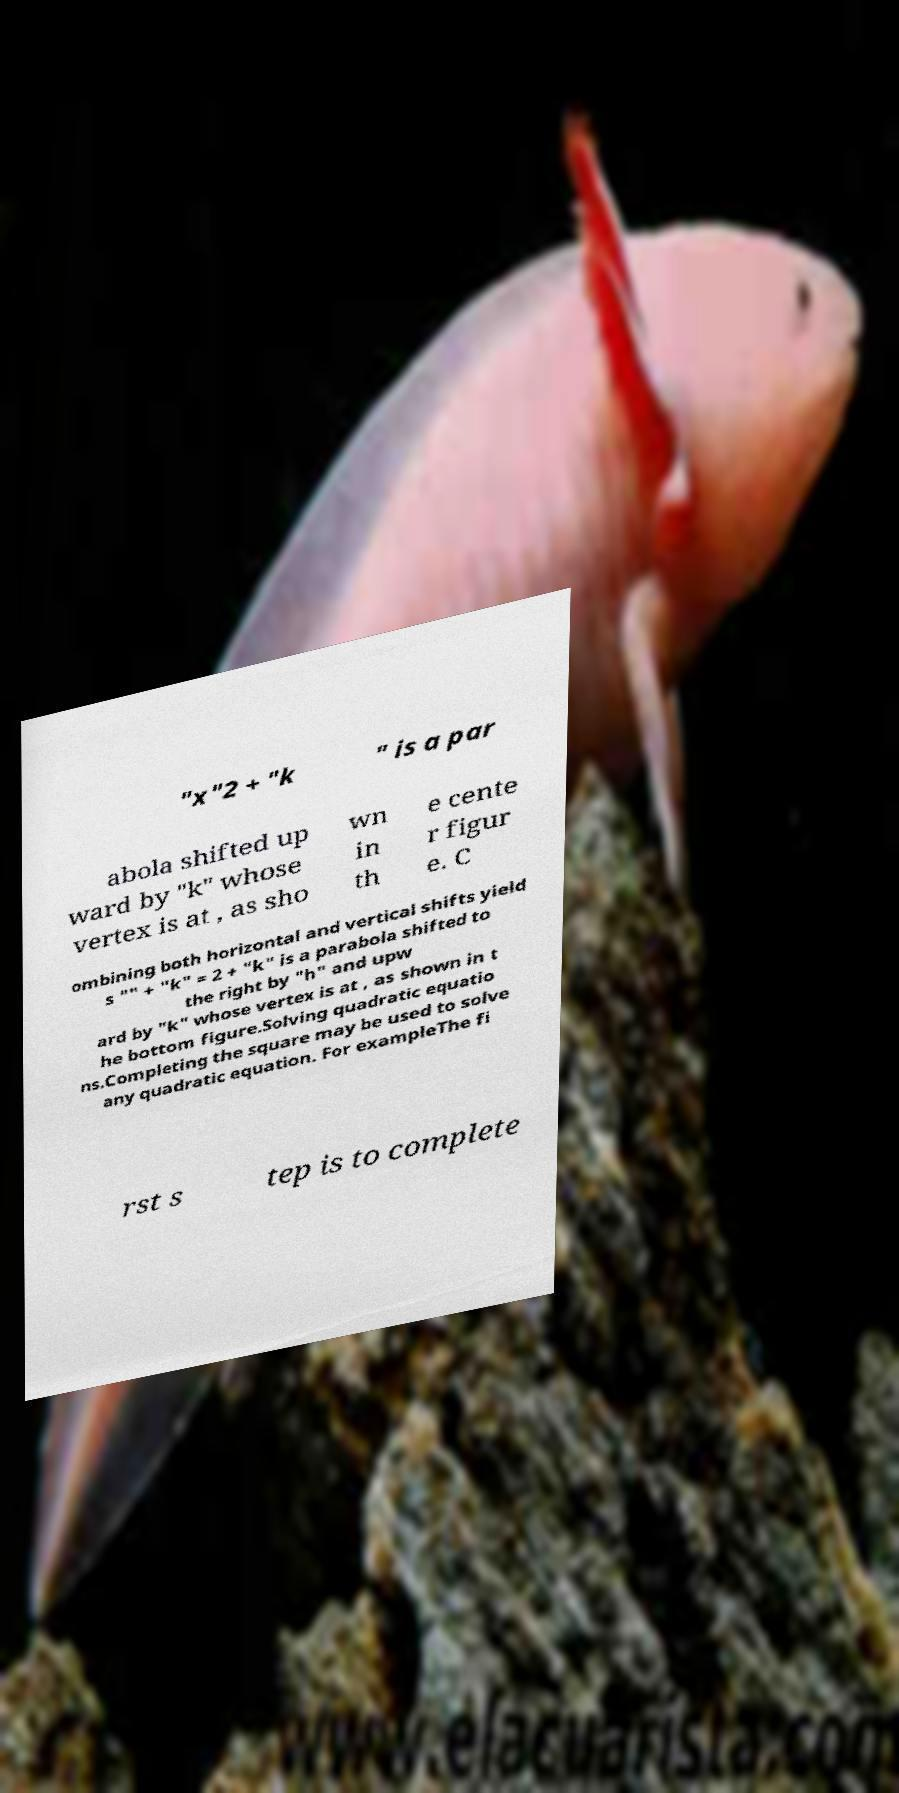Could you extract and type out the text from this image? "x"2 + "k " is a par abola shifted up ward by "k" whose vertex is at , as sho wn in th e cente r figur e. C ombining both horizontal and vertical shifts yield s "" + "k" = 2 + "k" is a parabola shifted to the right by "h" and upw ard by "k" whose vertex is at , as shown in t he bottom figure.Solving quadratic equatio ns.Completing the square may be used to solve any quadratic equation. For exampleThe fi rst s tep is to complete 